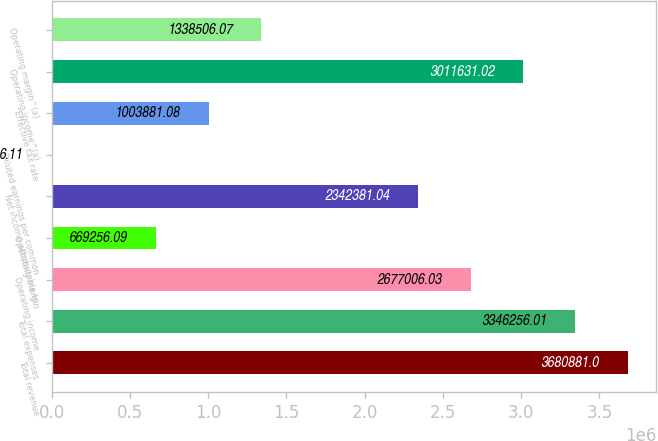Convert chart to OTSL. <chart><loc_0><loc_0><loc_500><loc_500><bar_chart><fcel>Total revenue<fcel>Total expenses<fcel>Operating income<fcel>Operating margin<fcel>Net income attributable to<fcel>Diluted earnings per common<fcel>Effective tax rate<fcel>Operating income^(a)<fcel>Operating margin^(a)<nl><fcel>3.68088e+06<fcel>3.34626e+06<fcel>2.67701e+06<fcel>669256<fcel>2.34238e+06<fcel>6.11<fcel>1.00388e+06<fcel>3.01163e+06<fcel>1.33851e+06<nl></chart> 